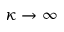<formula> <loc_0><loc_0><loc_500><loc_500>\kappa \rightarrow \infty</formula> 